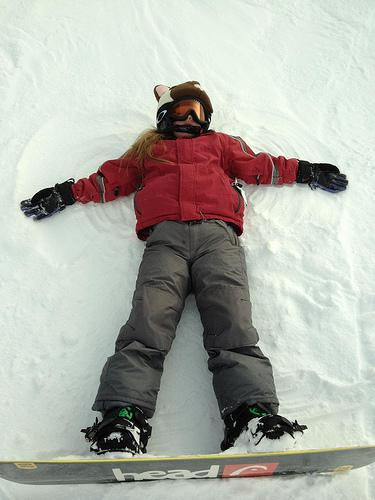Question: why is the girl laying in the snow?
Choices:
A. Making snow angel.
B. Fell on skis.
C. Making snow fort.
D. Having snowball fight.
Answer with the letter. Answer: A Question: what is attached to the girl's feet?
Choices:
A. Skis.
B. Roller skates.
C. Snowboard.
D. Shoes.
Answer with the letter. Answer: C Question: what color is the girl's coat?
Choices:
A. Red.
B. Blue.
C. Green.
D. Yellow.
Answer with the letter. Answer: A Question: what color are the girl's pants?
Choices:
A. Black.
B. Gray.
C. White.
D. Blue.
Answer with the letter. Answer: B Question: when was this taken?
Choices:
A. Summer.
B. Spring.
C. Autumn.
D. Winter.
Answer with the letter. Answer: D Question: what is on the girl's eyes?
Choices:
A. Goggles.
B. Face paint.
C. Eye patch.
D. False eyelashes.
Answer with the letter. Answer: A Question: what is on the girl's head?
Choices:
A. Bow.
B. Hat.
C. Bird.
D. Ponytail.
Answer with the letter. Answer: B 